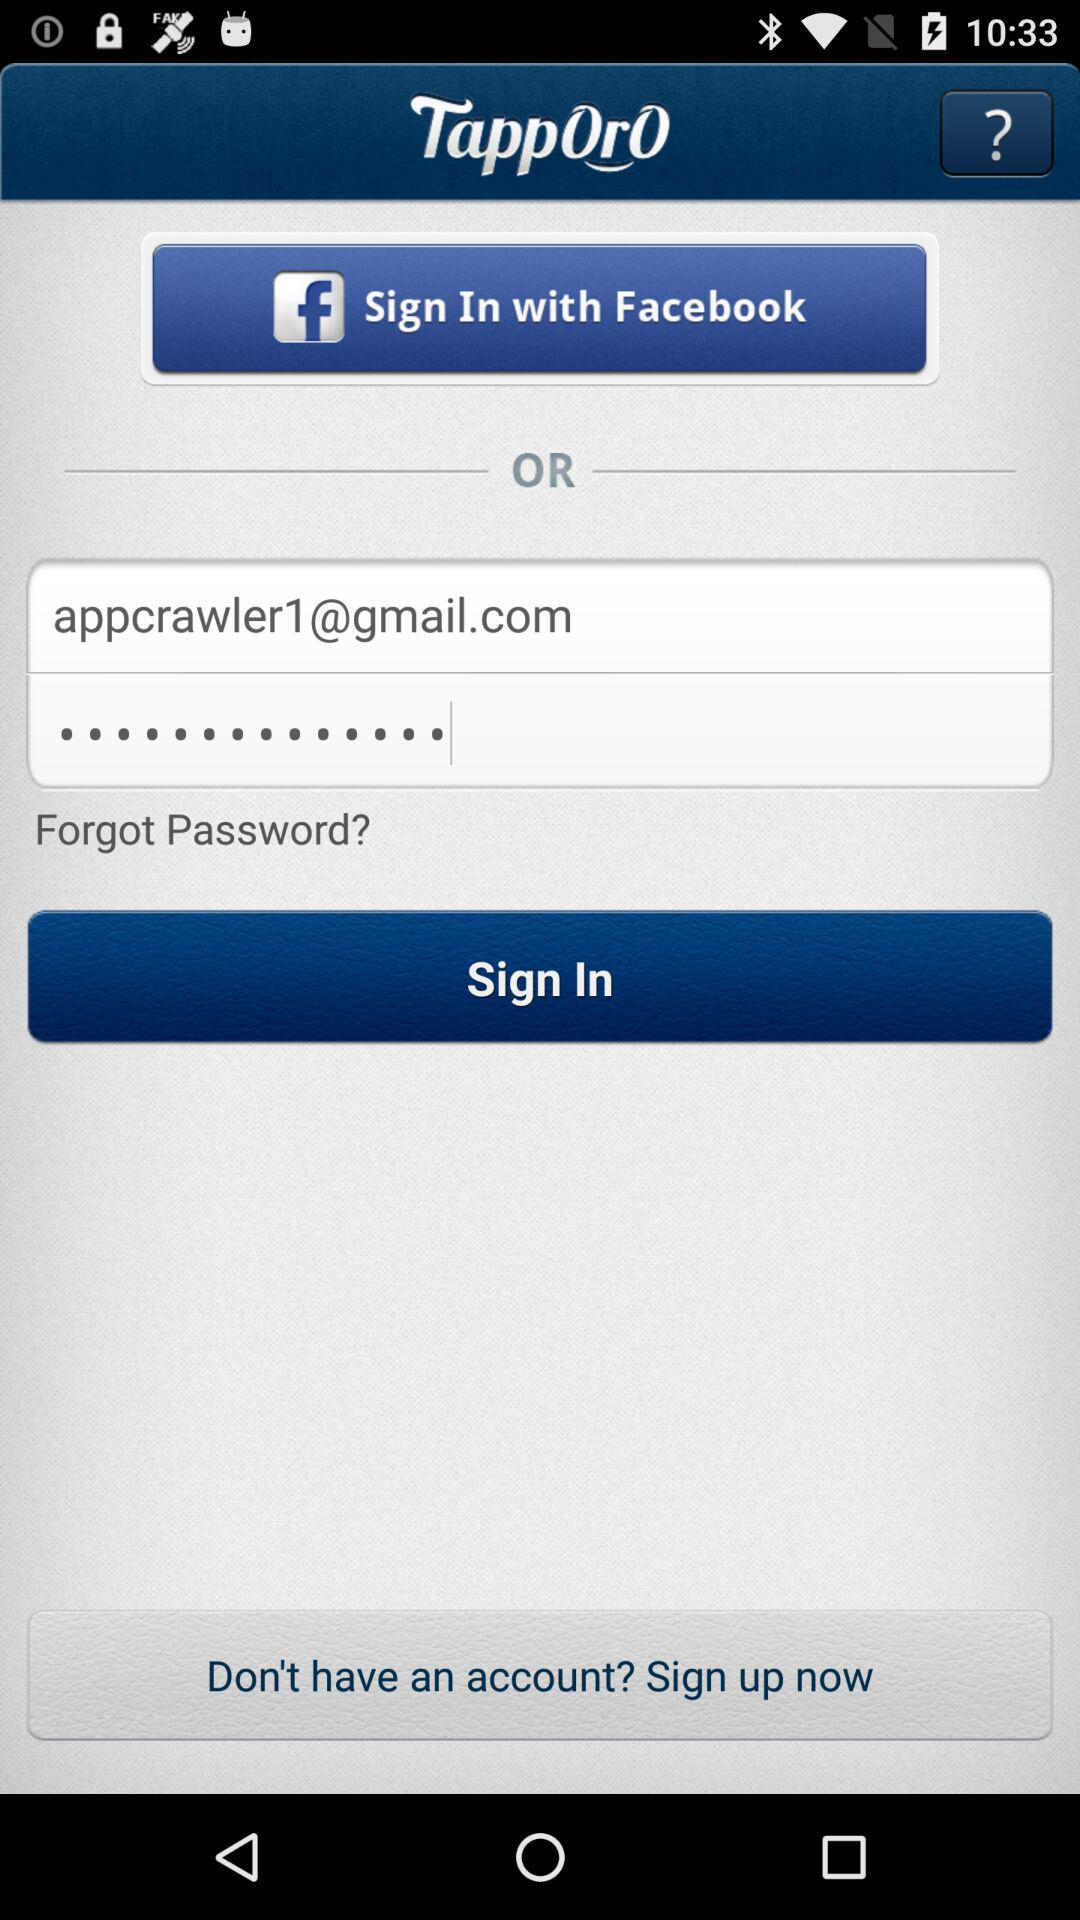What is the email address? The email address is appcrawler1@gmail.com. 